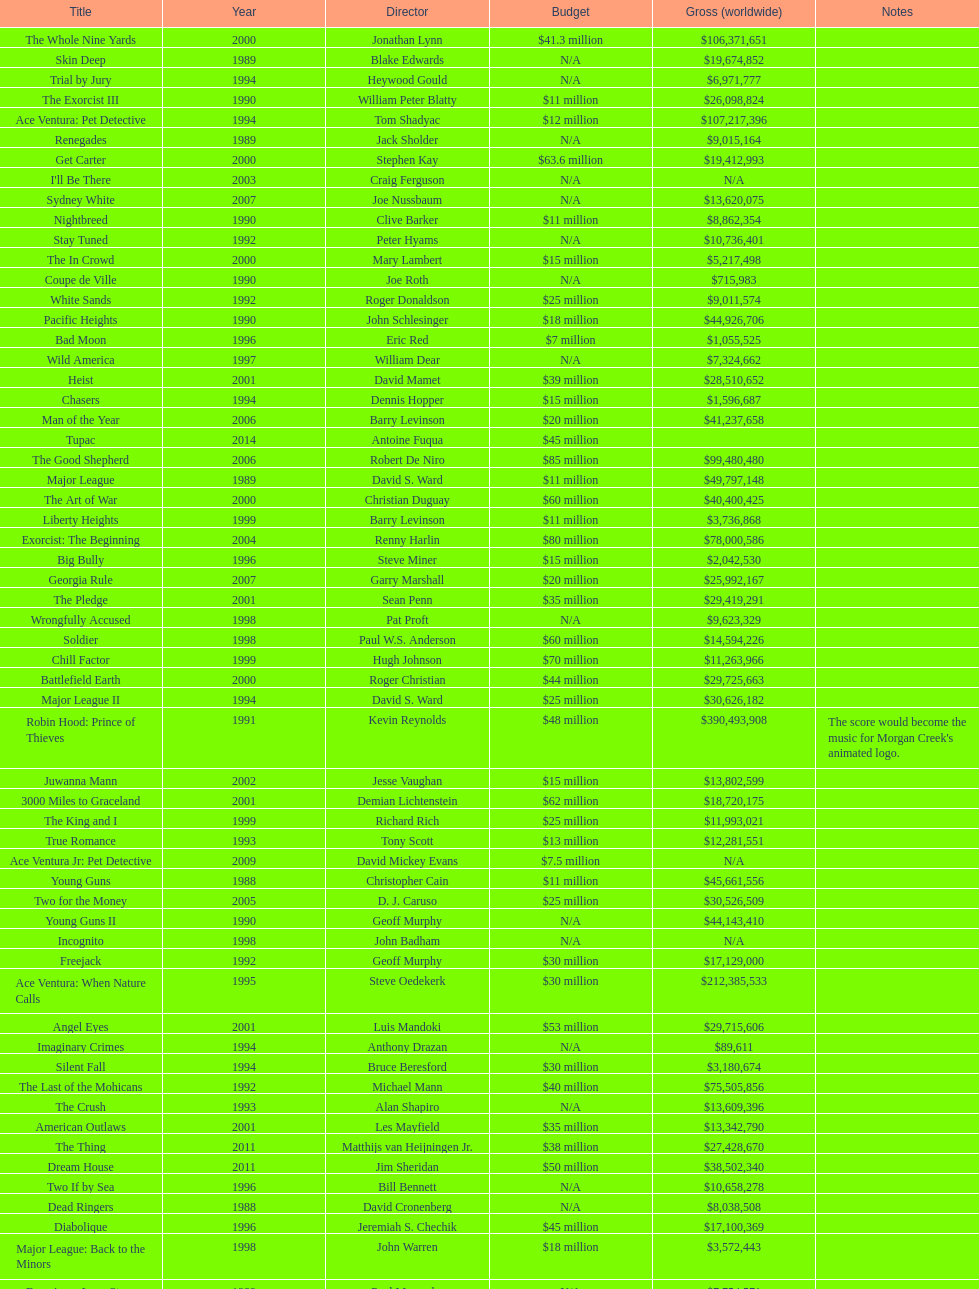What was the only movie with a 48 million dollar budget? Robin Hood: Prince of Thieves. 